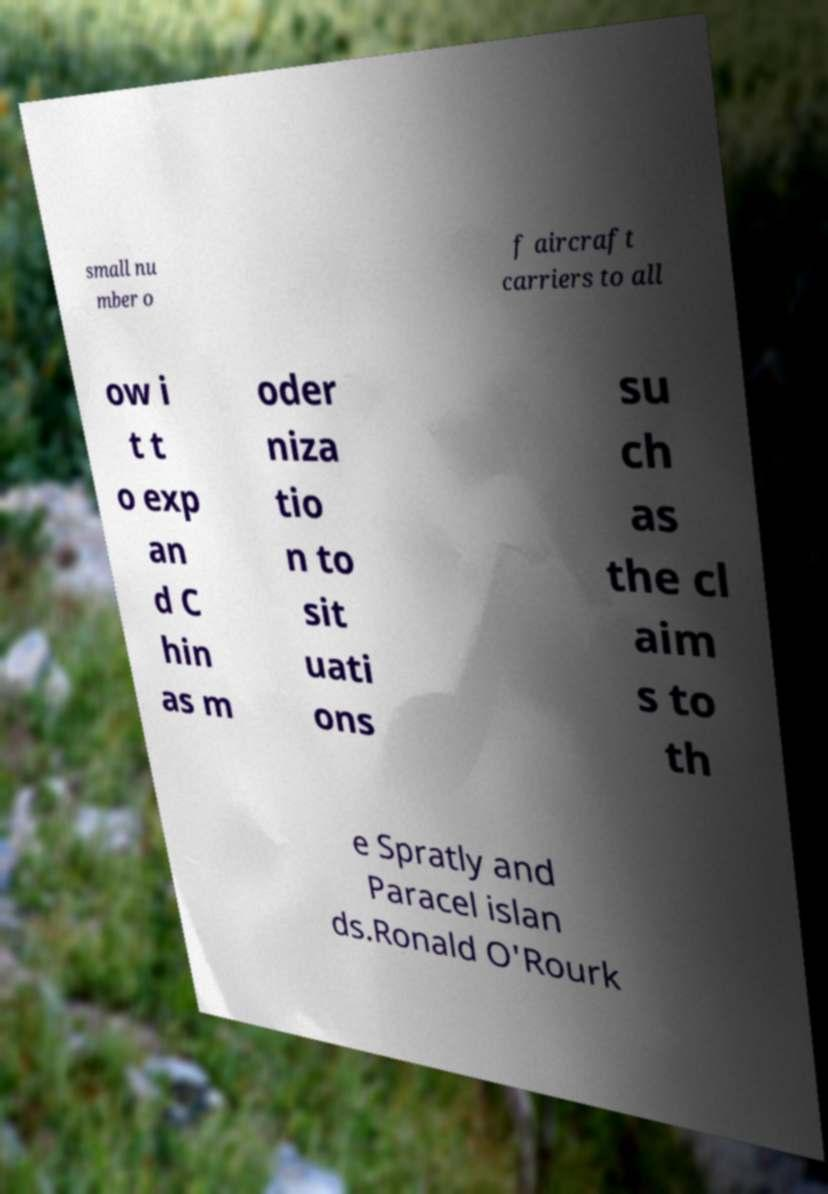Please read and relay the text visible in this image. What does it say? small nu mber o f aircraft carriers to all ow i t t o exp an d C hin as m oder niza tio n to sit uati ons su ch as the cl aim s to th e Spratly and Paracel islan ds.Ronald O'Rourk 